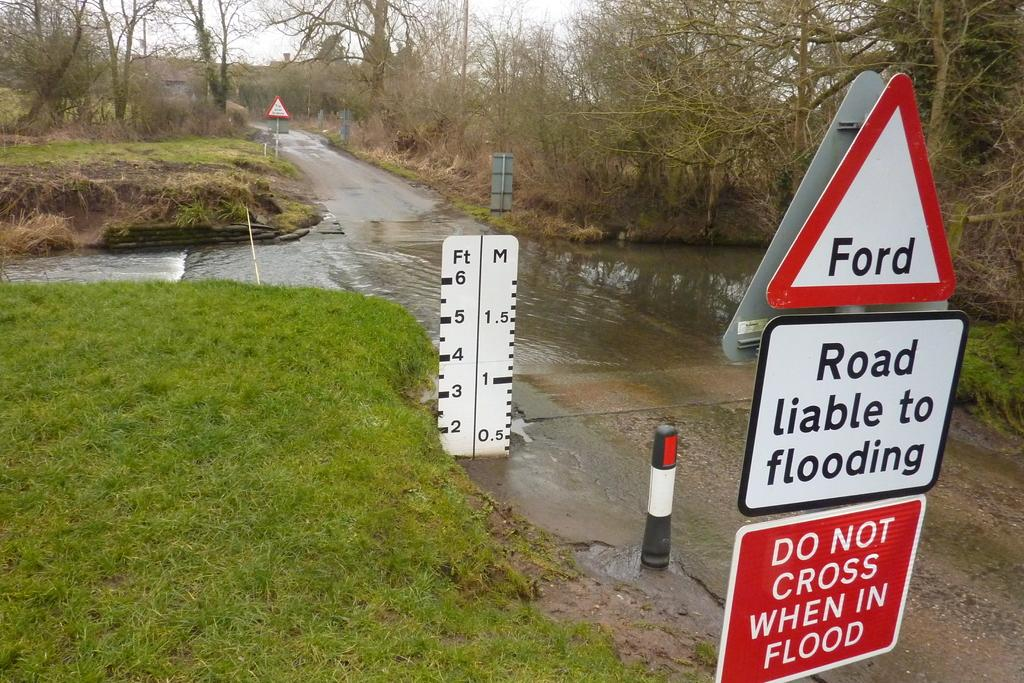<image>
Provide a brief description of the given image. A residential street that has a lot of standing water has a sign posted Road liable to flooding Do not cross when in flood. 